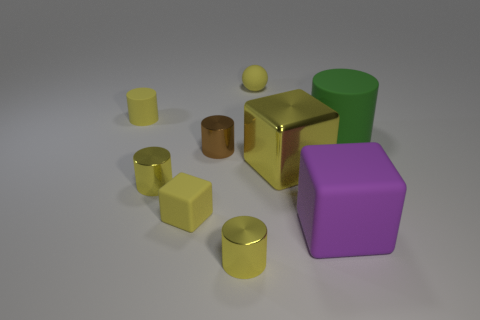Is the number of big yellow metallic balls less than the number of green matte cylinders?
Provide a short and direct response. Yes. Is there a metallic cylinder that is behind the large matte thing that is in front of the tiny cube?
Your answer should be very brief. Yes. There is a big purple thing that is made of the same material as the tiny yellow cube; what is its shape?
Your response must be concise. Cube. Are there any other things that have the same color as the big metal block?
Offer a very short reply. Yes. There is a brown thing that is the same shape as the big green object; what material is it?
Make the answer very short. Metal. What number of other objects are the same size as the green thing?
Your response must be concise. 2. What is the size of the matte cylinder that is the same color as the shiny cube?
Provide a short and direct response. Small. Do the big thing that is behind the brown cylinder and the big purple rubber thing have the same shape?
Your answer should be very brief. No. How many other things are the same shape as the green object?
Your answer should be compact. 4. There is a yellow matte thing that is in front of the green cylinder; what shape is it?
Offer a very short reply. Cube. 